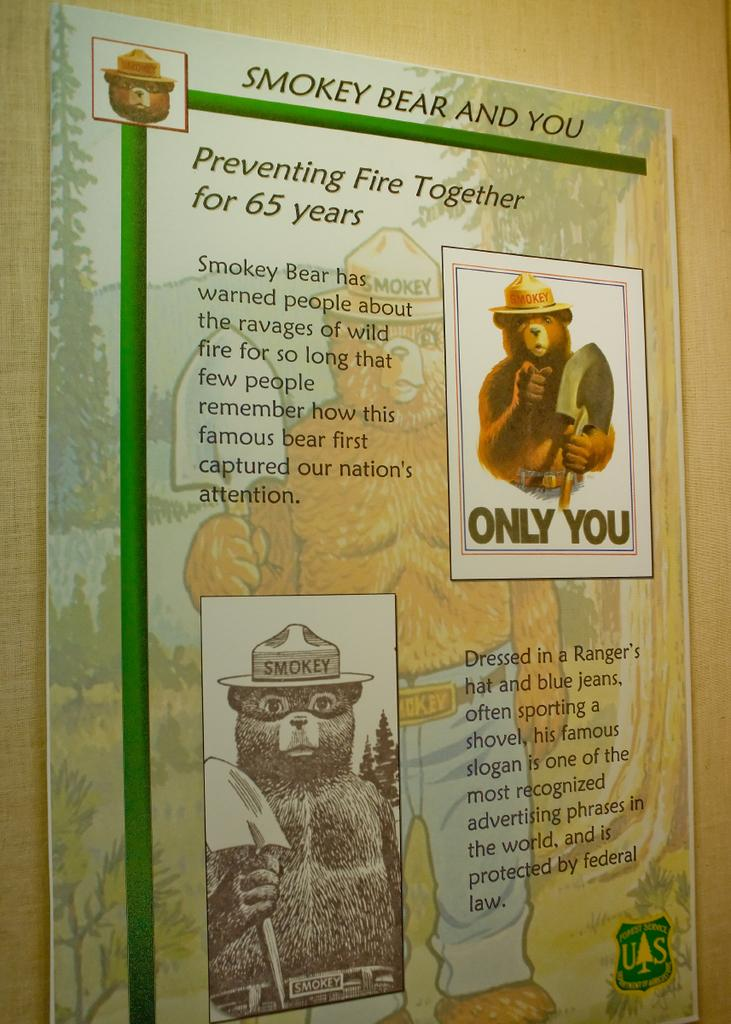Provide a one-sentence caption for the provided image. A poster entitled Smoky Bear and You features images of the bear. 